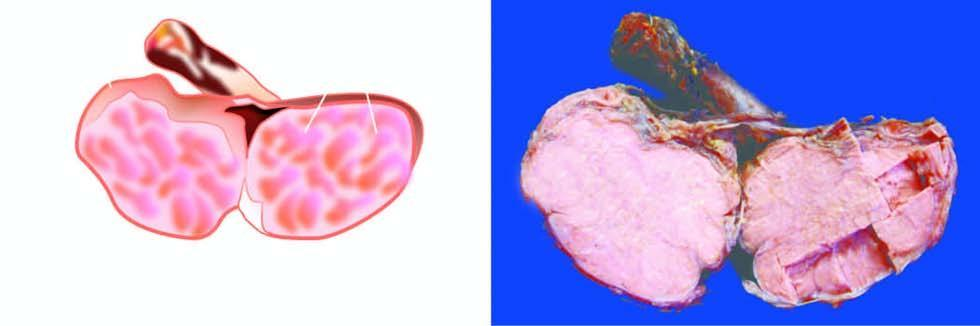what shows replacement of the entire testis by lobulated, homogeneous, grey-white mass?
Answer the question using a single word or phrase. Sectioned surface 